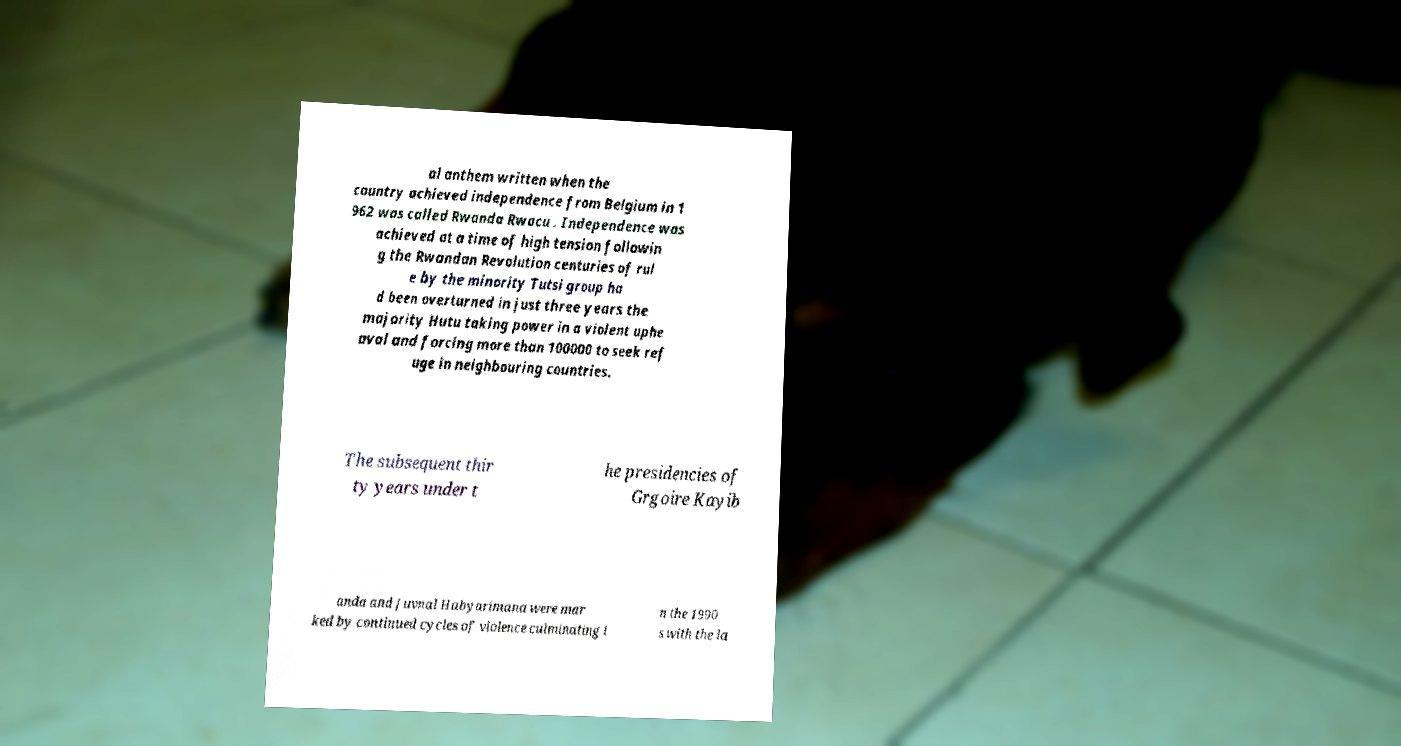Can you accurately transcribe the text from the provided image for me? al anthem written when the country achieved independence from Belgium in 1 962 was called Rwanda Rwacu . Independence was achieved at a time of high tension followin g the Rwandan Revolution centuries of rul e by the minority Tutsi group ha d been overturned in just three years the majority Hutu taking power in a violent uphe aval and forcing more than 100000 to seek ref uge in neighbouring countries. The subsequent thir ty years under t he presidencies of Grgoire Kayib anda and Juvnal Habyarimana were mar ked by continued cycles of violence culminating i n the 1990 s with the la 